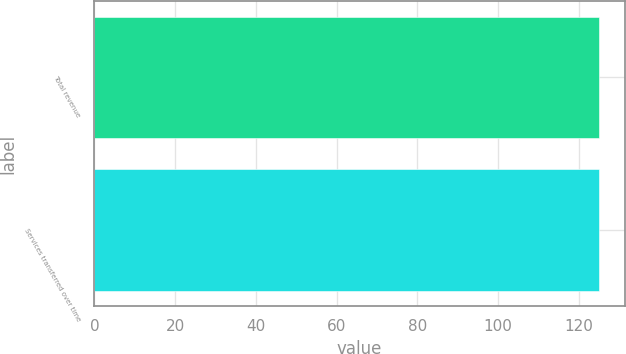<chart> <loc_0><loc_0><loc_500><loc_500><bar_chart><fcel>Total revenue<fcel>Services transferred over time<nl><fcel>125<fcel>125.1<nl></chart> 